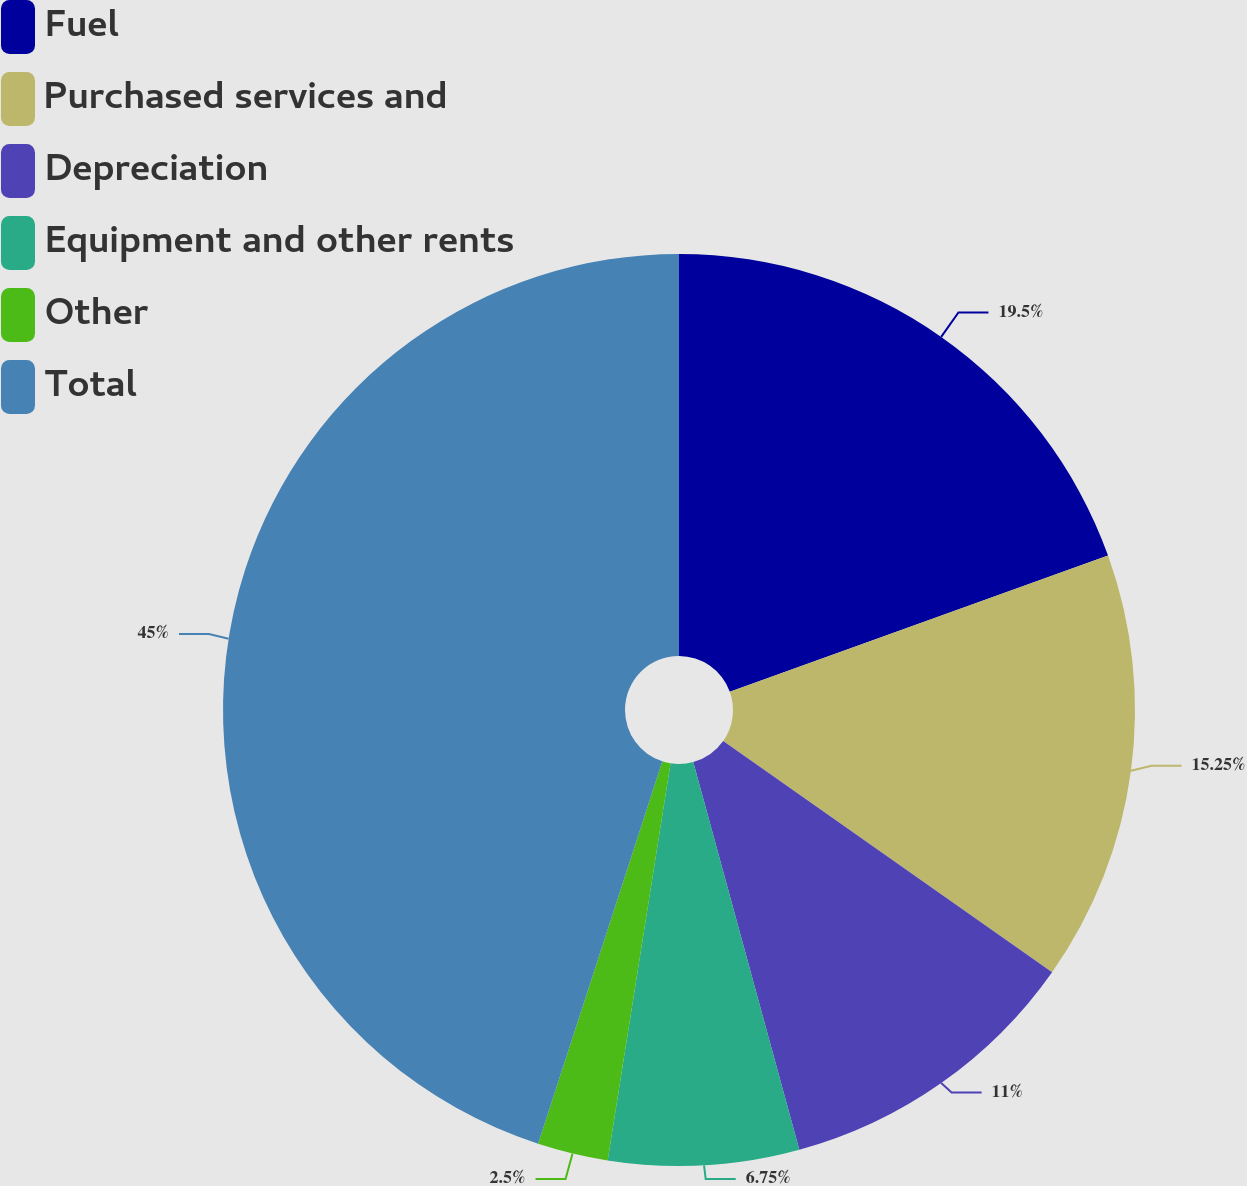Convert chart. <chart><loc_0><loc_0><loc_500><loc_500><pie_chart><fcel>Fuel<fcel>Purchased services and<fcel>Depreciation<fcel>Equipment and other rents<fcel>Other<fcel>Total<nl><fcel>19.5%<fcel>15.25%<fcel>11.0%<fcel>6.75%<fcel>2.5%<fcel>45.0%<nl></chart> 